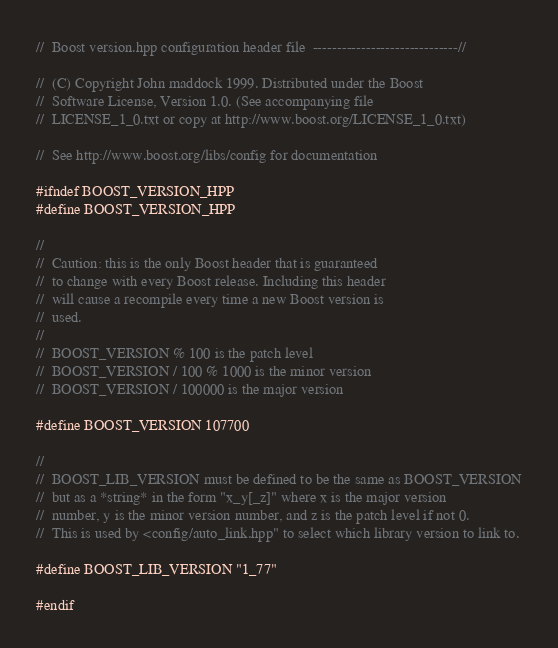<code> <loc_0><loc_0><loc_500><loc_500><_C++_>//  Boost version.hpp configuration header file  ------------------------------//

//  (C) Copyright John maddock 1999. Distributed under the Boost
//  Software License, Version 1.0. (See accompanying file
//  LICENSE_1_0.txt or copy at http://www.boost.org/LICENSE_1_0.txt)

//  See http://www.boost.org/libs/config for documentation

#ifndef BOOST_VERSION_HPP
#define BOOST_VERSION_HPP

//
//  Caution: this is the only Boost header that is guaranteed
//  to change with every Boost release. Including this header
//  will cause a recompile every time a new Boost version is
//  used.
//
//  BOOST_VERSION % 100 is the patch level
//  BOOST_VERSION / 100 % 1000 is the minor version
//  BOOST_VERSION / 100000 is the major version

#define BOOST_VERSION 107700

//
//  BOOST_LIB_VERSION must be defined to be the same as BOOST_VERSION
//  but as a *string* in the form "x_y[_z]" where x is the major version
//  number, y is the minor version number, and z is the patch level if not 0.
//  This is used by <config/auto_link.hpp" to select which library version to link to.

#define BOOST_LIB_VERSION "1_77"

#endif
</code> 